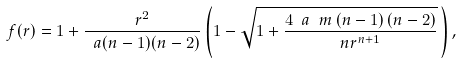Convert formula to latex. <formula><loc_0><loc_0><loc_500><loc_500>f ( r ) = 1 + \frac { r ^ { 2 } } { \ a ( n - 1 ) ( n - 2 ) } \left ( 1 - \sqrt { 1 + \frac { 4 \ a \ m \left ( n - 1 \right ) \left ( n - 2 \right ) } { n r ^ { n + 1 } } } \, \right ) ,</formula> 